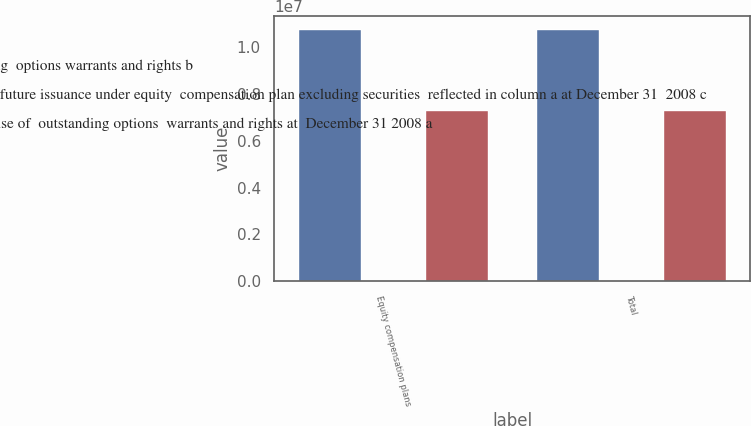Convert chart. <chart><loc_0><loc_0><loc_500><loc_500><stacked_bar_chart><ecel><fcel>Equity compensation plans<fcel>Total<nl><fcel>Weightedaverage exercise  price of outstanding  options warrants and rights b<fcel>1.07891e+07<fcel>1.07891e+07<nl><fcel>Number of securities remaining available  for future issuance under equity  compensation plan excluding securities  reflected in column a at December 31  2008 c<fcel>36.31<fcel>36.31<nl><fcel>Number of securities to be  issued upon exercise of  outstanding options  warrants and rights at  December 31 2008 a<fcel>7.33364e+06<fcel>7.33364e+06<nl></chart> 